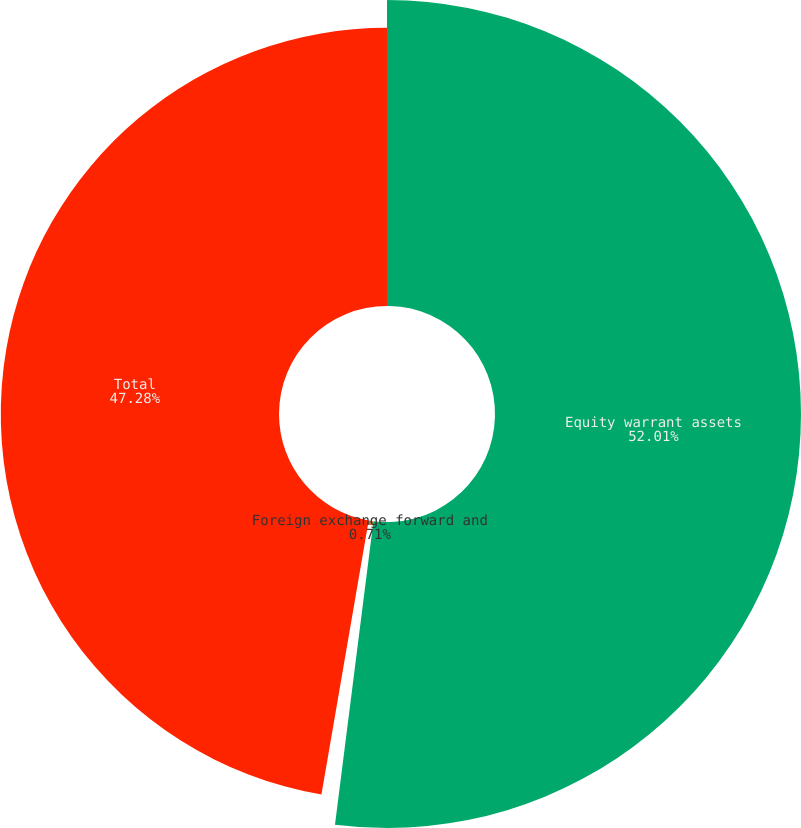<chart> <loc_0><loc_0><loc_500><loc_500><pie_chart><fcel>Equity warrant assets<fcel>Foreign exchange forward and<fcel>Total<nl><fcel>52.0%<fcel>0.71%<fcel>47.28%<nl></chart> 